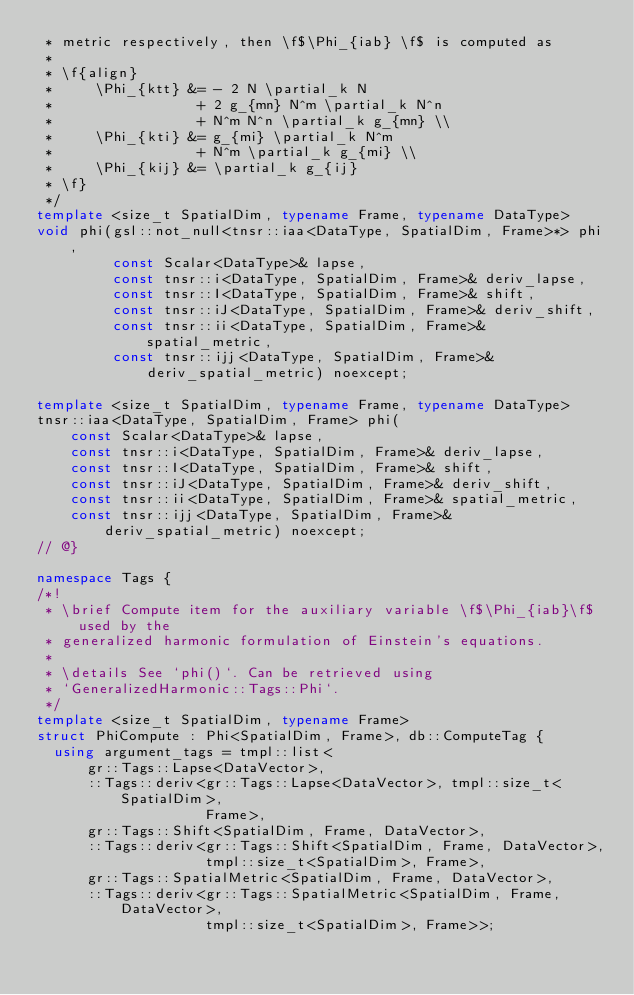<code> <loc_0><loc_0><loc_500><loc_500><_C++_> * metric respectively, then \f$\Phi_{iab} \f$ is computed as
 *
 * \f{align}
 *     \Phi_{ktt} &= - 2 N \partial_k N
 *                 + 2 g_{mn} N^m \partial_k N^n
 *                 + N^m N^n \partial_k g_{mn} \\
 *     \Phi_{kti} &= g_{mi} \partial_k N^m
 *                 + N^m \partial_k g_{mi} \\
 *     \Phi_{kij} &= \partial_k g_{ij}
 * \f}
 */
template <size_t SpatialDim, typename Frame, typename DataType>
void phi(gsl::not_null<tnsr::iaa<DataType, SpatialDim, Frame>*> phi,
         const Scalar<DataType>& lapse,
         const tnsr::i<DataType, SpatialDim, Frame>& deriv_lapse,
         const tnsr::I<DataType, SpatialDim, Frame>& shift,
         const tnsr::iJ<DataType, SpatialDim, Frame>& deriv_shift,
         const tnsr::ii<DataType, SpatialDim, Frame>& spatial_metric,
         const tnsr::ijj<DataType, SpatialDim, Frame>&
             deriv_spatial_metric) noexcept;

template <size_t SpatialDim, typename Frame, typename DataType>
tnsr::iaa<DataType, SpatialDim, Frame> phi(
    const Scalar<DataType>& lapse,
    const tnsr::i<DataType, SpatialDim, Frame>& deriv_lapse,
    const tnsr::I<DataType, SpatialDim, Frame>& shift,
    const tnsr::iJ<DataType, SpatialDim, Frame>& deriv_shift,
    const tnsr::ii<DataType, SpatialDim, Frame>& spatial_metric,
    const tnsr::ijj<DataType, SpatialDim, Frame>&
        deriv_spatial_metric) noexcept;
// @}

namespace Tags {
/*!
 * \brief Compute item for the auxiliary variable \f$\Phi_{iab}\f$ used by the
 * generalized harmonic formulation of Einstein's equations.
 *
 * \details See `phi()`. Can be retrieved using
 * `GeneralizedHarmonic::Tags::Phi`.
 */
template <size_t SpatialDim, typename Frame>
struct PhiCompute : Phi<SpatialDim, Frame>, db::ComputeTag {
  using argument_tags = tmpl::list<
      gr::Tags::Lapse<DataVector>,
      ::Tags::deriv<gr::Tags::Lapse<DataVector>, tmpl::size_t<SpatialDim>,
                    Frame>,
      gr::Tags::Shift<SpatialDim, Frame, DataVector>,
      ::Tags::deriv<gr::Tags::Shift<SpatialDim, Frame, DataVector>,
                    tmpl::size_t<SpatialDim>, Frame>,
      gr::Tags::SpatialMetric<SpatialDim, Frame, DataVector>,
      ::Tags::deriv<gr::Tags::SpatialMetric<SpatialDim, Frame, DataVector>,
                    tmpl::size_t<SpatialDim>, Frame>>;
</code> 